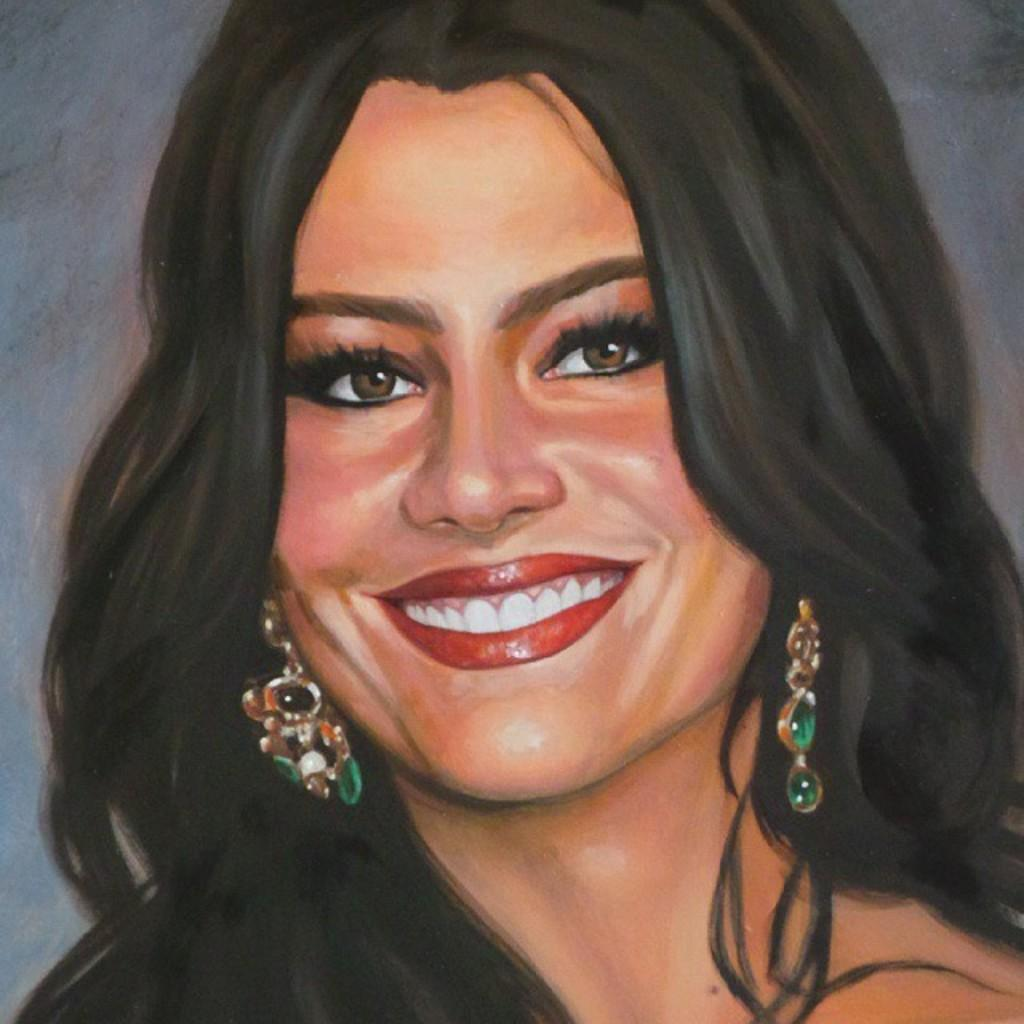What is depicted in the image? There is a painting of a woman in the image. What is the woman doing in the painting? The woman is smiling in the painting. What accessory is the woman wearing in the painting? The woman is wearing earrings in the painting. What type of fan is visible in the painting? There is no fan present in the painting; it features a woman who is smiling and wearing earrings. 